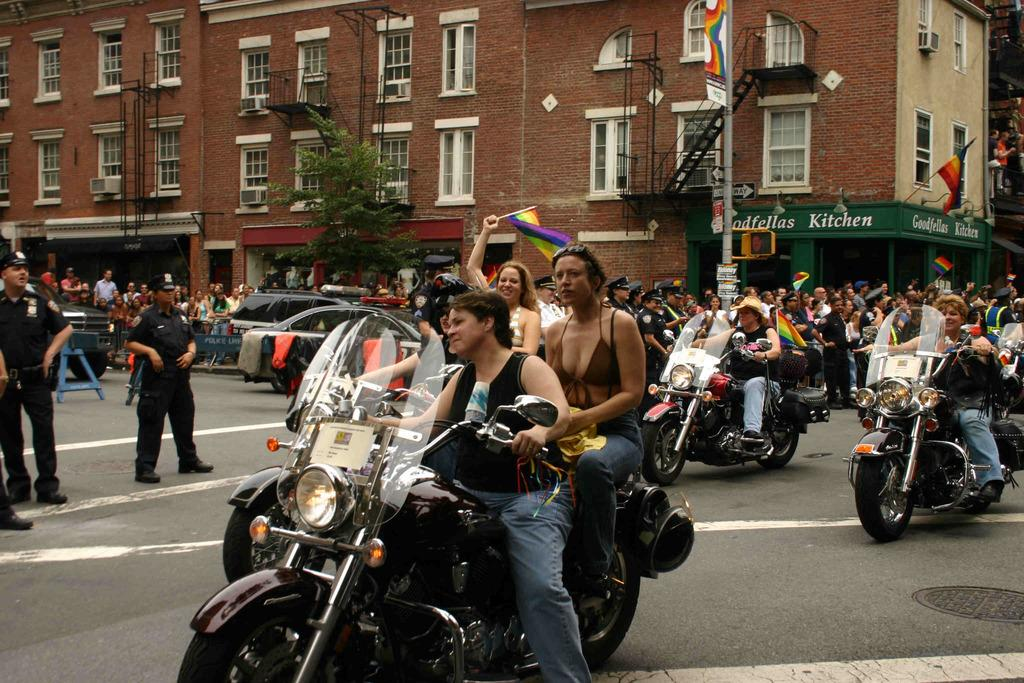Where was the image taken? The image is taken outdoors. What is the weather like in the image? It is sunny in the image. What are the people in the image doing? The people are riding bikes. On what surface are the people riding their bikes? The people are on a road. What can be seen in the background of the image? There is a tree and a building in the background of the image. What is the price of the goose in the image? There is no goose present in the image, so it is not possible to determine its price. What type of apparel are the people wearing in the image? The provided facts do not mention the apparel worn by the people in the image. 